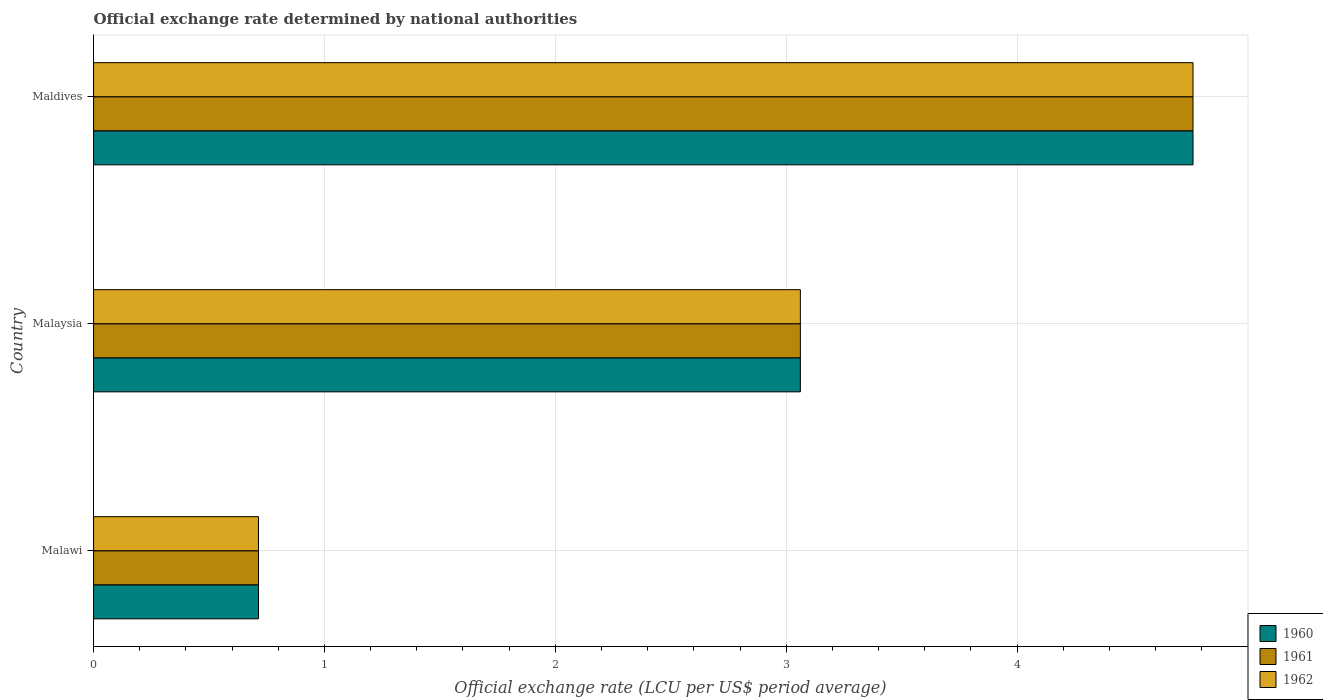How many different coloured bars are there?
Ensure brevity in your answer.  3. Are the number of bars per tick equal to the number of legend labels?
Ensure brevity in your answer.  Yes. How many bars are there on the 1st tick from the top?
Your answer should be very brief. 3. How many bars are there on the 3rd tick from the bottom?
Your answer should be very brief. 3. What is the label of the 1st group of bars from the top?
Make the answer very short. Maldives. In how many cases, is the number of bars for a given country not equal to the number of legend labels?
Make the answer very short. 0. What is the official exchange rate in 1960 in Malawi?
Offer a very short reply. 0.71. Across all countries, what is the maximum official exchange rate in 1961?
Give a very brief answer. 4.76. Across all countries, what is the minimum official exchange rate in 1960?
Provide a short and direct response. 0.71. In which country was the official exchange rate in 1960 maximum?
Keep it short and to the point. Maldives. In which country was the official exchange rate in 1960 minimum?
Offer a very short reply. Malawi. What is the total official exchange rate in 1960 in the graph?
Offer a terse response. 8.54. What is the difference between the official exchange rate in 1961 in Malawi and that in Malaysia?
Your response must be concise. -2.35. What is the difference between the official exchange rate in 1960 in Malawi and the official exchange rate in 1961 in Maldives?
Make the answer very short. -4.05. What is the average official exchange rate in 1961 per country?
Your response must be concise. 2.85. In how many countries, is the official exchange rate in 1960 greater than 2.8 LCU?
Provide a short and direct response. 2. What is the ratio of the official exchange rate in 1961 in Malaysia to that in Maldives?
Give a very brief answer. 0.64. Is the difference between the official exchange rate in 1961 in Malawi and Malaysia greater than the difference between the official exchange rate in 1960 in Malawi and Malaysia?
Your answer should be very brief. No. What is the difference between the highest and the second highest official exchange rate in 1960?
Your answer should be very brief. 1.7. What is the difference between the highest and the lowest official exchange rate in 1961?
Provide a short and direct response. 4.05. Is the sum of the official exchange rate in 1960 in Malaysia and Maldives greater than the maximum official exchange rate in 1961 across all countries?
Make the answer very short. Yes. What does the 1st bar from the top in Malawi represents?
Make the answer very short. 1962. What does the 1st bar from the bottom in Malaysia represents?
Offer a very short reply. 1960. How many bars are there?
Provide a succinct answer. 9. Are the values on the major ticks of X-axis written in scientific E-notation?
Your answer should be very brief. No. Does the graph contain any zero values?
Provide a short and direct response. No. What is the title of the graph?
Provide a short and direct response. Official exchange rate determined by national authorities. Does "2015" appear as one of the legend labels in the graph?
Ensure brevity in your answer.  No. What is the label or title of the X-axis?
Provide a succinct answer. Official exchange rate (LCU per US$ period average). What is the Official exchange rate (LCU per US$ period average) of 1960 in Malawi?
Make the answer very short. 0.71. What is the Official exchange rate (LCU per US$ period average) of 1961 in Malawi?
Make the answer very short. 0.71. What is the Official exchange rate (LCU per US$ period average) of 1962 in Malawi?
Give a very brief answer. 0.71. What is the Official exchange rate (LCU per US$ period average) in 1960 in Malaysia?
Offer a very short reply. 3.06. What is the Official exchange rate (LCU per US$ period average) of 1961 in Malaysia?
Offer a very short reply. 3.06. What is the Official exchange rate (LCU per US$ period average) in 1962 in Malaysia?
Keep it short and to the point. 3.06. What is the Official exchange rate (LCU per US$ period average) in 1960 in Maldives?
Give a very brief answer. 4.76. What is the Official exchange rate (LCU per US$ period average) in 1961 in Maldives?
Ensure brevity in your answer.  4.76. What is the Official exchange rate (LCU per US$ period average) in 1962 in Maldives?
Offer a very short reply. 4.76. Across all countries, what is the maximum Official exchange rate (LCU per US$ period average) in 1960?
Your answer should be compact. 4.76. Across all countries, what is the maximum Official exchange rate (LCU per US$ period average) of 1961?
Keep it short and to the point. 4.76. Across all countries, what is the maximum Official exchange rate (LCU per US$ period average) in 1962?
Offer a terse response. 4.76. Across all countries, what is the minimum Official exchange rate (LCU per US$ period average) of 1960?
Offer a very short reply. 0.71. Across all countries, what is the minimum Official exchange rate (LCU per US$ period average) of 1961?
Keep it short and to the point. 0.71. Across all countries, what is the minimum Official exchange rate (LCU per US$ period average) in 1962?
Provide a short and direct response. 0.71. What is the total Official exchange rate (LCU per US$ period average) of 1960 in the graph?
Provide a short and direct response. 8.54. What is the total Official exchange rate (LCU per US$ period average) of 1961 in the graph?
Keep it short and to the point. 8.54. What is the total Official exchange rate (LCU per US$ period average) of 1962 in the graph?
Make the answer very short. 8.54. What is the difference between the Official exchange rate (LCU per US$ period average) in 1960 in Malawi and that in Malaysia?
Ensure brevity in your answer.  -2.35. What is the difference between the Official exchange rate (LCU per US$ period average) of 1961 in Malawi and that in Malaysia?
Make the answer very short. -2.35. What is the difference between the Official exchange rate (LCU per US$ period average) in 1962 in Malawi and that in Malaysia?
Make the answer very short. -2.35. What is the difference between the Official exchange rate (LCU per US$ period average) in 1960 in Malawi and that in Maldives?
Give a very brief answer. -4.05. What is the difference between the Official exchange rate (LCU per US$ period average) of 1961 in Malawi and that in Maldives?
Give a very brief answer. -4.05. What is the difference between the Official exchange rate (LCU per US$ period average) of 1962 in Malawi and that in Maldives?
Provide a succinct answer. -4.05. What is the difference between the Official exchange rate (LCU per US$ period average) of 1960 in Malaysia and that in Maldives?
Offer a terse response. -1.7. What is the difference between the Official exchange rate (LCU per US$ period average) of 1961 in Malaysia and that in Maldives?
Keep it short and to the point. -1.7. What is the difference between the Official exchange rate (LCU per US$ period average) of 1962 in Malaysia and that in Maldives?
Your answer should be very brief. -1.7. What is the difference between the Official exchange rate (LCU per US$ period average) in 1960 in Malawi and the Official exchange rate (LCU per US$ period average) in 1961 in Malaysia?
Keep it short and to the point. -2.35. What is the difference between the Official exchange rate (LCU per US$ period average) in 1960 in Malawi and the Official exchange rate (LCU per US$ period average) in 1962 in Malaysia?
Ensure brevity in your answer.  -2.35. What is the difference between the Official exchange rate (LCU per US$ period average) of 1961 in Malawi and the Official exchange rate (LCU per US$ period average) of 1962 in Malaysia?
Offer a terse response. -2.35. What is the difference between the Official exchange rate (LCU per US$ period average) of 1960 in Malawi and the Official exchange rate (LCU per US$ period average) of 1961 in Maldives?
Keep it short and to the point. -4.05. What is the difference between the Official exchange rate (LCU per US$ period average) in 1960 in Malawi and the Official exchange rate (LCU per US$ period average) in 1962 in Maldives?
Your answer should be very brief. -4.05. What is the difference between the Official exchange rate (LCU per US$ period average) in 1961 in Malawi and the Official exchange rate (LCU per US$ period average) in 1962 in Maldives?
Keep it short and to the point. -4.05. What is the difference between the Official exchange rate (LCU per US$ period average) of 1960 in Malaysia and the Official exchange rate (LCU per US$ period average) of 1961 in Maldives?
Keep it short and to the point. -1.7. What is the difference between the Official exchange rate (LCU per US$ period average) of 1960 in Malaysia and the Official exchange rate (LCU per US$ period average) of 1962 in Maldives?
Provide a short and direct response. -1.7. What is the difference between the Official exchange rate (LCU per US$ period average) of 1961 in Malaysia and the Official exchange rate (LCU per US$ period average) of 1962 in Maldives?
Keep it short and to the point. -1.7. What is the average Official exchange rate (LCU per US$ period average) of 1960 per country?
Your response must be concise. 2.85. What is the average Official exchange rate (LCU per US$ period average) of 1961 per country?
Provide a succinct answer. 2.85. What is the average Official exchange rate (LCU per US$ period average) in 1962 per country?
Your answer should be very brief. 2.85. What is the difference between the Official exchange rate (LCU per US$ period average) in 1961 and Official exchange rate (LCU per US$ period average) in 1962 in Malawi?
Make the answer very short. 0. What is the difference between the Official exchange rate (LCU per US$ period average) of 1960 and Official exchange rate (LCU per US$ period average) of 1961 in Malaysia?
Your response must be concise. 0. What is the difference between the Official exchange rate (LCU per US$ period average) in 1960 and Official exchange rate (LCU per US$ period average) in 1962 in Malaysia?
Your answer should be very brief. 0. What is the difference between the Official exchange rate (LCU per US$ period average) in 1960 and Official exchange rate (LCU per US$ period average) in 1961 in Maldives?
Make the answer very short. 0. What is the ratio of the Official exchange rate (LCU per US$ period average) of 1960 in Malawi to that in Malaysia?
Keep it short and to the point. 0.23. What is the ratio of the Official exchange rate (LCU per US$ period average) of 1961 in Malawi to that in Malaysia?
Offer a terse response. 0.23. What is the ratio of the Official exchange rate (LCU per US$ period average) of 1962 in Malawi to that in Malaysia?
Give a very brief answer. 0.23. What is the ratio of the Official exchange rate (LCU per US$ period average) in 1960 in Malawi to that in Maldives?
Keep it short and to the point. 0.15. What is the ratio of the Official exchange rate (LCU per US$ period average) in 1961 in Malawi to that in Maldives?
Offer a very short reply. 0.15. What is the ratio of the Official exchange rate (LCU per US$ period average) in 1962 in Malawi to that in Maldives?
Provide a succinct answer. 0.15. What is the ratio of the Official exchange rate (LCU per US$ period average) of 1960 in Malaysia to that in Maldives?
Ensure brevity in your answer.  0.64. What is the ratio of the Official exchange rate (LCU per US$ period average) in 1961 in Malaysia to that in Maldives?
Give a very brief answer. 0.64. What is the ratio of the Official exchange rate (LCU per US$ period average) in 1962 in Malaysia to that in Maldives?
Make the answer very short. 0.64. What is the difference between the highest and the second highest Official exchange rate (LCU per US$ period average) of 1960?
Provide a short and direct response. 1.7. What is the difference between the highest and the second highest Official exchange rate (LCU per US$ period average) of 1961?
Ensure brevity in your answer.  1.7. What is the difference between the highest and the second highest Official exchange rate (LCU per US$ period average) in 1962?
Your answer should be very brief. 1.7. What is the difference between the highest and the lowest Official exchange rate (LCU per US$ period average) of 1960?
Ensure brevity in your answer.  4.05. What is the difference between the highest and the lowest Official exchange rate (LCU per US$ period average) in 1961?
Your answer should be very brief. 4.05. What is the difference between the highest and the lowest Official exchange rate (LCU per US$ period average) in 1962?
Offer a terse response. 4.05. 